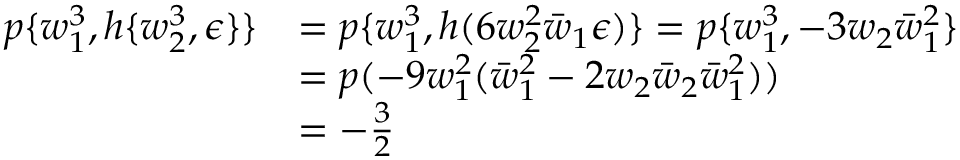Convert formula to latex. <formula><loc_0><loc_0><loc_500><loc_500>\begin{array} { r l } { p \{ w _ { 1 } ^ { 3 } , h \{ w _ { 2 } ^ { 3 } , \epsilon \} \} } & { = p \{ w _ { 1 } ^ { 3 } , h ( 6 w _ { 2 } ^ { 2 } \bar { w } _ { 1 } \epsilon ) \} = p \{ w _ { 1 } ^ { 3 } , - 3 w _ { 2 } \bar { w } _ { 1 } ^ { 2 } \} } \\ & { = p ( - 9 w _ { 1 } ^ { 2 } ( \bar { w } _ { 1 } ^ { 2 } - 2 w _ { 2 } \bar { w } _ { 2 } \bar { w } _ { 1 } ^ { 2 } ) ) } \\ & { = - \frac { 3 } { 2 } } \end{array}</formula> 